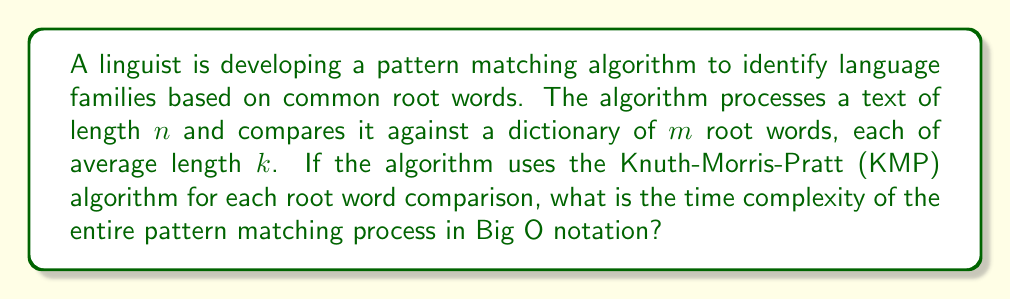Can you answer this question? To solve this problem, let's break it down step-by-step:

1. The Knuth-Morris-Pratt (KMP) algorithm has a time complexity of $O(n + k)$ for matching a pattern of length $k$ in a text of length $n$.

2. In this case, we need to perform this matching for each of the $m$ root words in the dictionary.

3. For each root word:
   - The text length is $n$
   - The pattern length (root word length) is $k$
   - The time complexity for one root word is $O(n + k)$

4. We repeat this process $m$ times (once for each root word in the dictionary).

5. Therefore, the total time complexity is:

   $$O(m(n + k))$$

6. We can expand this:

   $$O(mn + mk)$$

7. Since $k$ (the average length of root words) is typically much smaller than $n$ (the length of the text being analyzed), we can consider $k$ as a constant factor.

8. In Big O notation, we drop constant factors, so $mk$ becomes less significant compared to $mn$ for large values of $n$.

Thus, the dominant term in the time complexity is $O(mn)$.
Answer: $O(mn)$ 